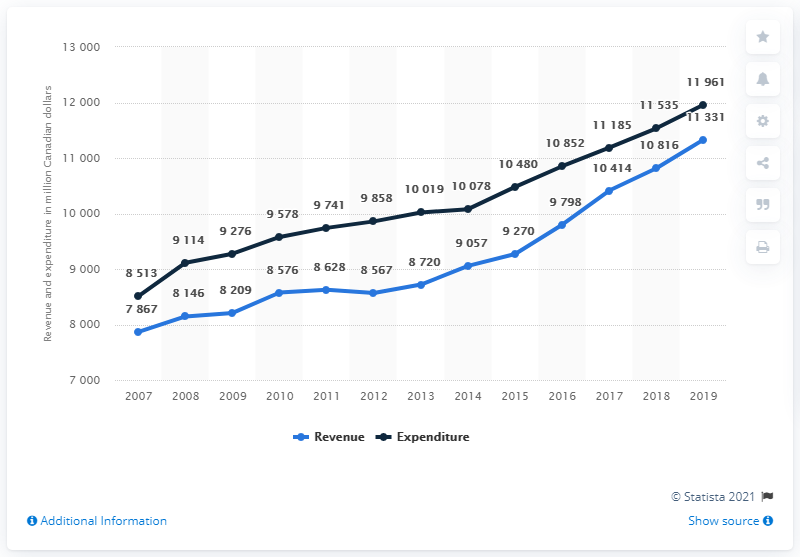Outline some significant characteristics in this image. From 2007 to 2008, the average revenue was approximately 8006.5. In 2019, the revenue of New Brunswick's provincial government was approximately 11,331 dollars. Which year contains the higher point on the graph? 2019. 